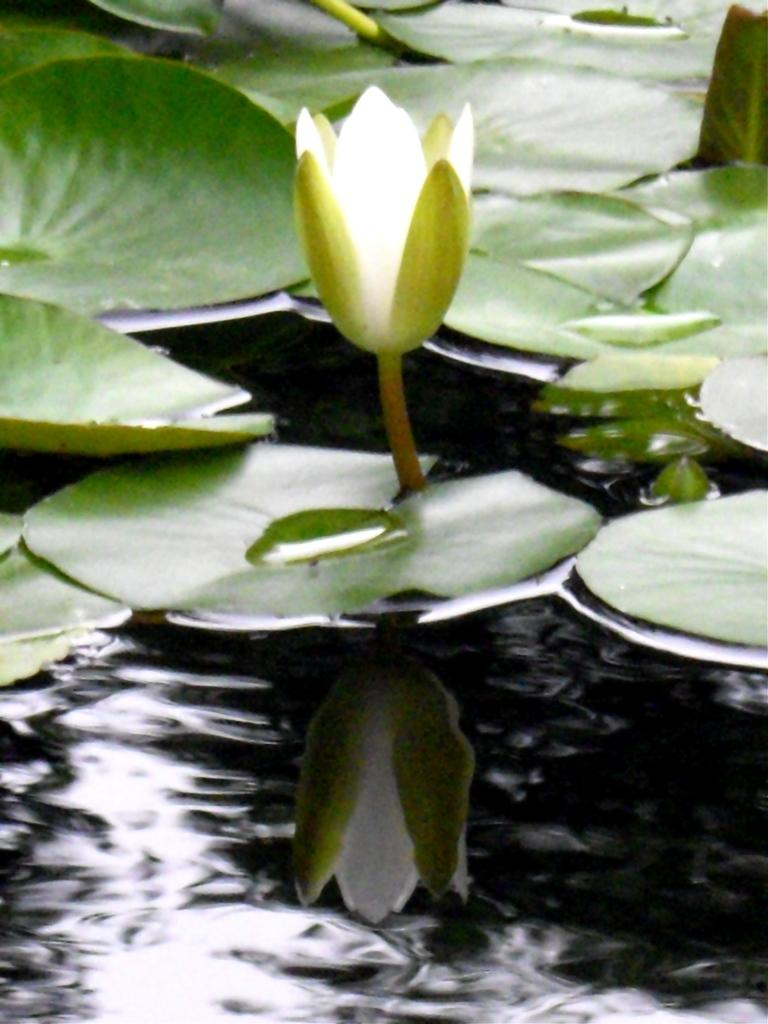What type of flower is in the image? There is a lotus flower in the image. Where is the lotus flower located in the image? The lotus flower is on the water surface. What else can be seen around the lotus flower in the image? There are many leaves around the lotus flower in the image. What is the title of the book that the lotus flower is reading in the image? There is no book or reading activity depicted in the image; it features a lotus flower on the water surface with surrounding leaves. 